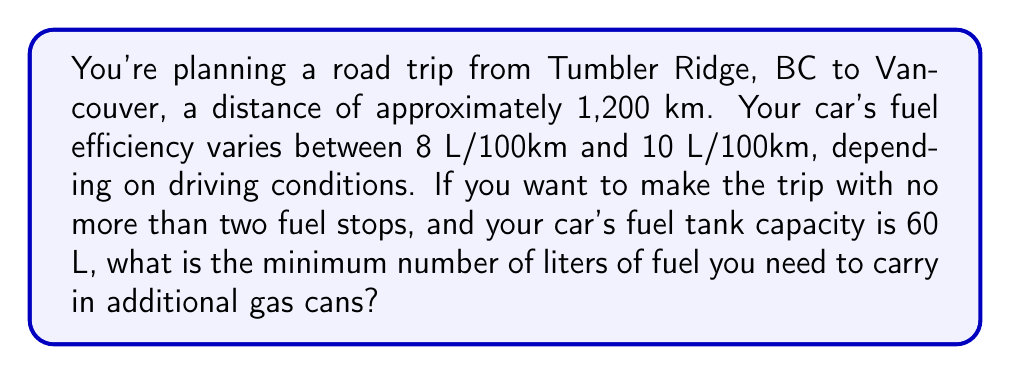Teach me how to tackle this problem. Let's approach this step-by-step:

1) First, let's set up our variables:
   Let $x$ be the number of liters of additional fuel needed.

2) We need to consider the worst-case scenario for fuel consumption, which is 10 L/100km.
   Fuel consumption for the trip: $1200 \text{ km} \times \frac{10 \text{ L}}{100 \text{ km}} = 120 \text{ L}$

3) The total available fuel should be greater than or equal to the fuel consumed:
   $$(60 \text{ L} \times 3) + x \geq 120 \text{ L}$$
   Here, $60 \text{ L} \times 3$ represents the fuel from three full tanks (initial full tank plus two refills).

4) Solve the inequality:
   $$180 + x \geq 120$$
   $$x \geq -60$$

5) Since $x$ can't be negative (we can't carry negative fuel), and we need the minimum amount, $x = 0$.

6) To verify:
   Total fuel available = $60 \text{ L} \times 3 = 180 \text{ L}$
   This is indeed greater than the 120 L needed for the worst-case scenario.

Therefore, you don't need to carry any additional fuel in gas cans.
Answer: 0 L 